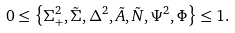Convert formula to latex. <formula><loc_0><loc_0><loc_500><loc_500>0 \leq \left \{ \Sigma _ { + } ^ { 2 } , \tilde { \Sigma } , \Delta ^ { 2 } , \tilde { A } , \tilde { N } , \Psi ^ { 2 } , \Phi \right \} \leq 1 .</formula> 